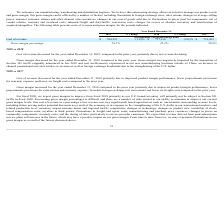According to Netgear's financial document, What accounted for the change in gross margin from 2017 to 2018? Due to improved product margin performance, lower proportionate provisions for sales returns and warranty expense, favorable foreign exchange rate movements and lower air freight costs compared to the prior year.. The document states: "mber 31, 2018 compared to the prior year primarily due to improved product margin performance, lower proportionate provisions for sales returns and wa..." Also, What was the cost of revenue in 2019? According to the financial document, $704,535 (in thousands). The relevant text states: "Cost of revenue $ 704,535 (1.8)% $ 717,118 (2.0)% $ 731,453..." Also, What accounted for the change in cost of revenue from 2018 to 2019? Due to net revenue declining. The document states: "r 31, 2019, compared to the prior year, primarily due to net revenue declining...." Additionally, Which year has the highest gross margin percentage? According to the financial document, 2018. The relevant text states: "2019 % Change 2018 % Change 2017..." Also, can you calculate: What is the gross margin percentage change from 2017 to 2018? Based on the calculation: 32.3%-29.6% , the result is 2.7 (percentage). This is based on the information: "Gross margin percentage 29.5% 32.3% 29.6% Gross margin percentage 29.5% 32.3% 29.6%..." The key data points involved are: 29.6, 32.3. Also, can you calculate: What was the percentage change in cost of revenue from 2017 to 2019? To answer this question, I need to perform calculations using the financial data. The calculation is: (704,535-731,453)/731,453 , which equals -3.68 (percentage). This is based on the information: "Cost of revenue $ 704,535 (1.8)% $ 717,118 (2.0)% $ 731,453 st of revenue $ 704,535 (1.8)% $ 717,118 (2.0)% $ 731,453..." The key data points involved are: 704,535, 731,453. 